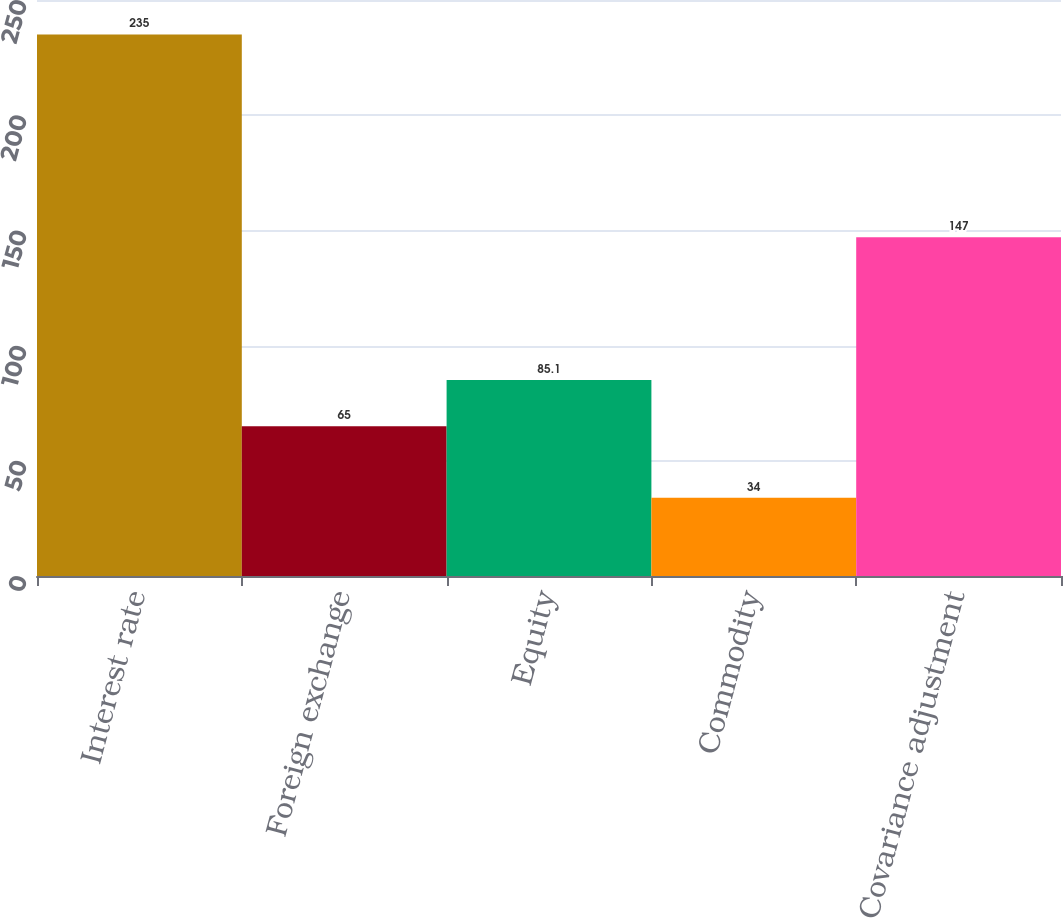Convert chart. <chart><loc_0><loc_0><loc_500><loc_500><bar_chart><fcel>Interest rate<fcel>Foreign exchange<fcel>Equity<fcel>Commodity<fcel>Covariance adjustment<nl><fcel>235<fcel>65<fcel>85.1<fcel>34<fcel>147<nl></chart> 